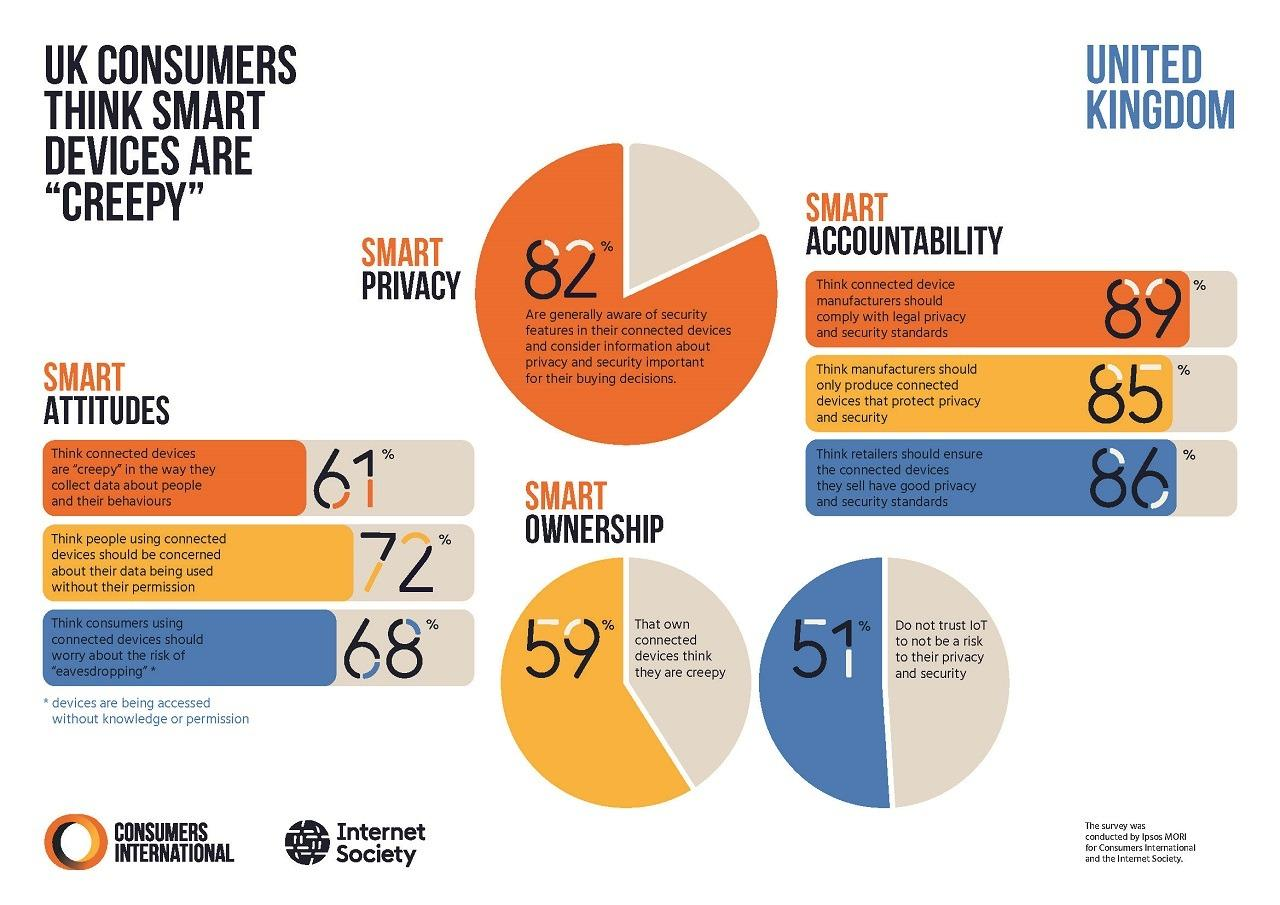Specify some key components in this picture. According to a survey of UK consumers, 11% believe that connected device manufacturers should not comply with legal privacy and security standards. According to a survey of UK consumers, 28% believe that people using connected devices should not be concerned about their data being used without their permission. A significant portion of UK consumers who own connected devices, 41%, do not find them creepy. According to a survey, only 14% of UK consumers believe that retailers should not prioritize privacy and security standards for connected devices they sell. 